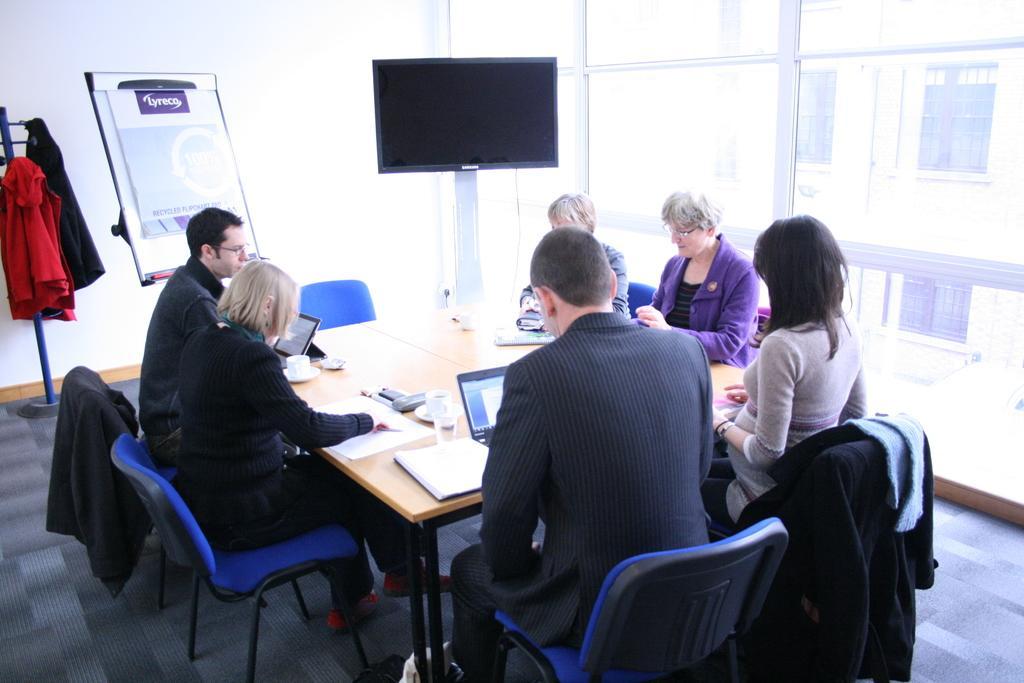Could you give a brief overview of what you see in this image? In this picture we can see a wall and a hanger and clothes on it ,and here there are group of people sitting on a chair, and in front there is the table and laptop, glass, and tea cup on it. and here is the television, and here is the glass, and at back there is the building. 